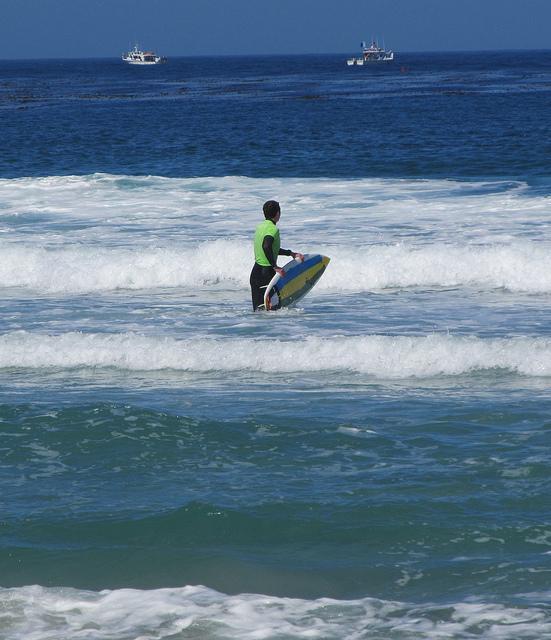How many boats are in the picture?
Give a very brief answer. 2. How many horses are grazing on the hill?
Give a very brief answer. 0. 